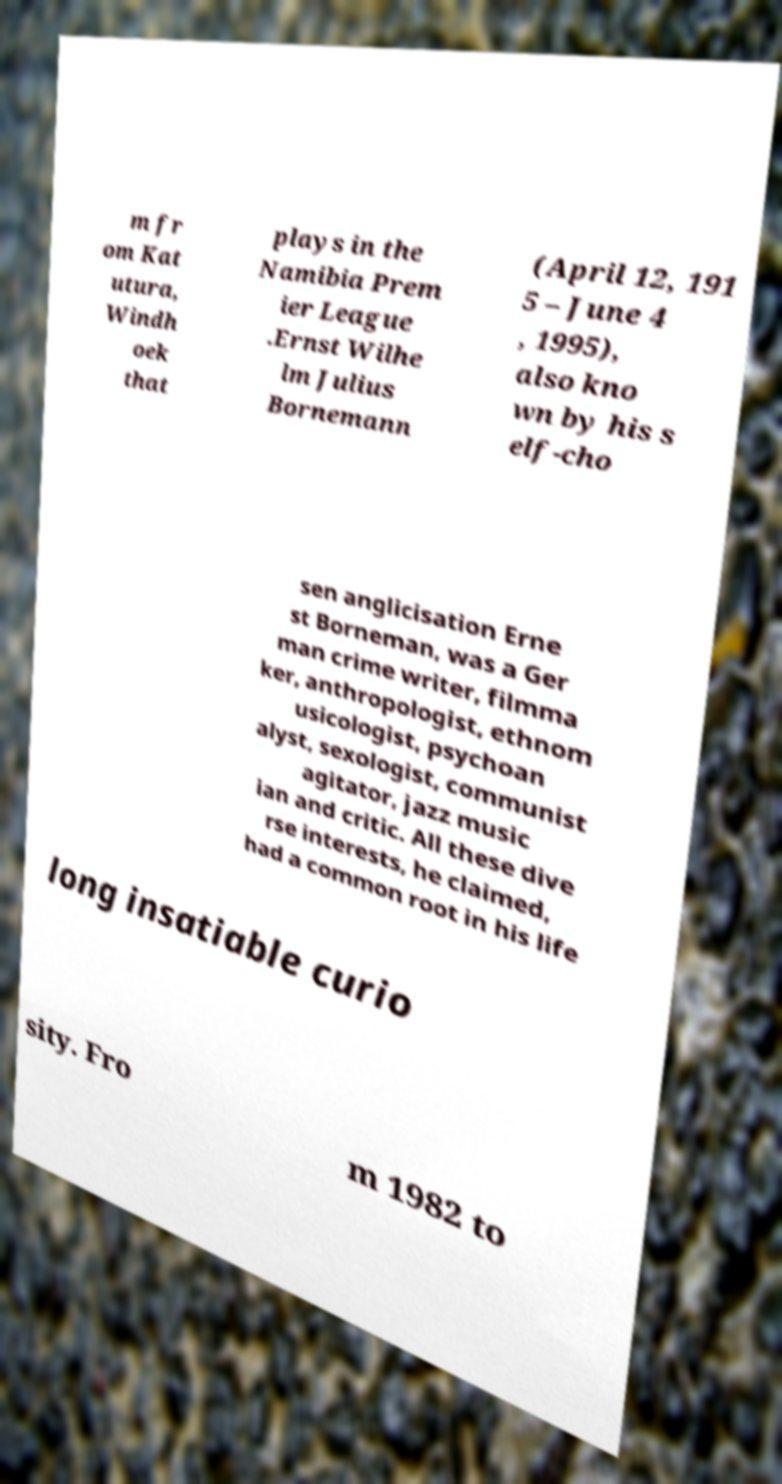Could you extract and type out the text from this image? m fr om Kat utura, Windh oek that plays in the Namibia Prem ier League .Ernst Wilhe lm Julius Bornemann (April 12, 191 5 – June 4 , 1995), also kno wn by his s elf-cho sen anglicisation Erne st Borneman, was a Ger man crime writer, filmma ker, anthropologist, ethnom usicologist, psychoan alyst, sexologist, communist agitator, jazz music ian and critic. All these dive rse interests, he claimed, had a common root in his life long insatiable curio sity. Fro m 1982 to 